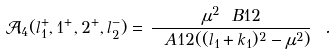<formula> <loc_0><loc_0><loc_500><loc_500>\mathcal { A } _ { 4 } ( l _ { 1 } ^ { + } , 1 ^ { + } , 2 ^ { + } , l _ { 2 } ^ { - } ) = \, \frac { \mu ^ { 2 } \ B { 1 } { 2 } } { \ A { 1 } { 2 } ( ( l _ { 1 } + k _ { 1 } ) ^ { 2 } - \mu ^ { 2 } ) } \ .</formula> 